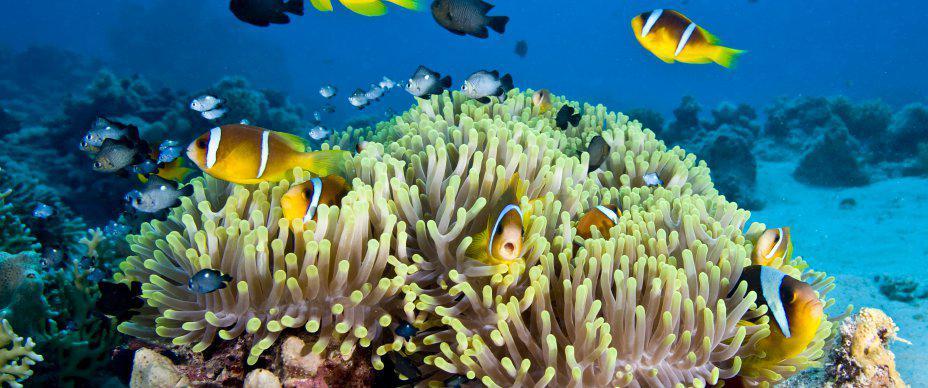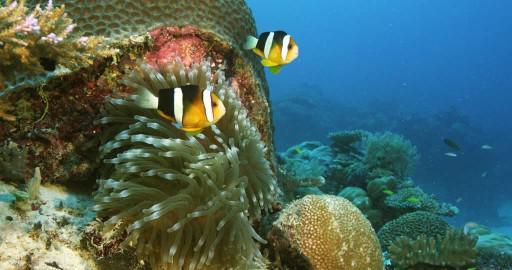The first image is the image on the left, the second image is the image on the right. Considering the images on both sides, is "A single fish is swimming near the sea plant in the image on the left." valid? Answer yes or no. No. The first image is the image on the left, the second image is the image on the right. Examine the images to the left and right. Is the description "Each image shows multiple fish with white stripes swimming above anemone tendrils, and the left image features anemone tendrils with non-tapered yellow tips." accurate? Answer yes or no. Yes. 